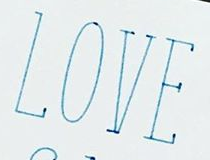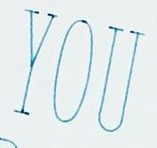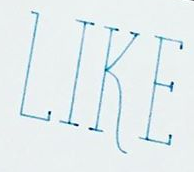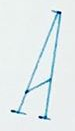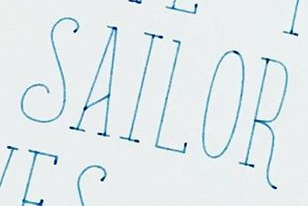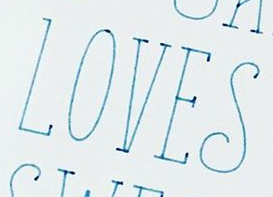What text is displayed in these images sequentially, separated by a semicolon? LOVE; YOU; LIKE; A; SAILOR; LOVES 